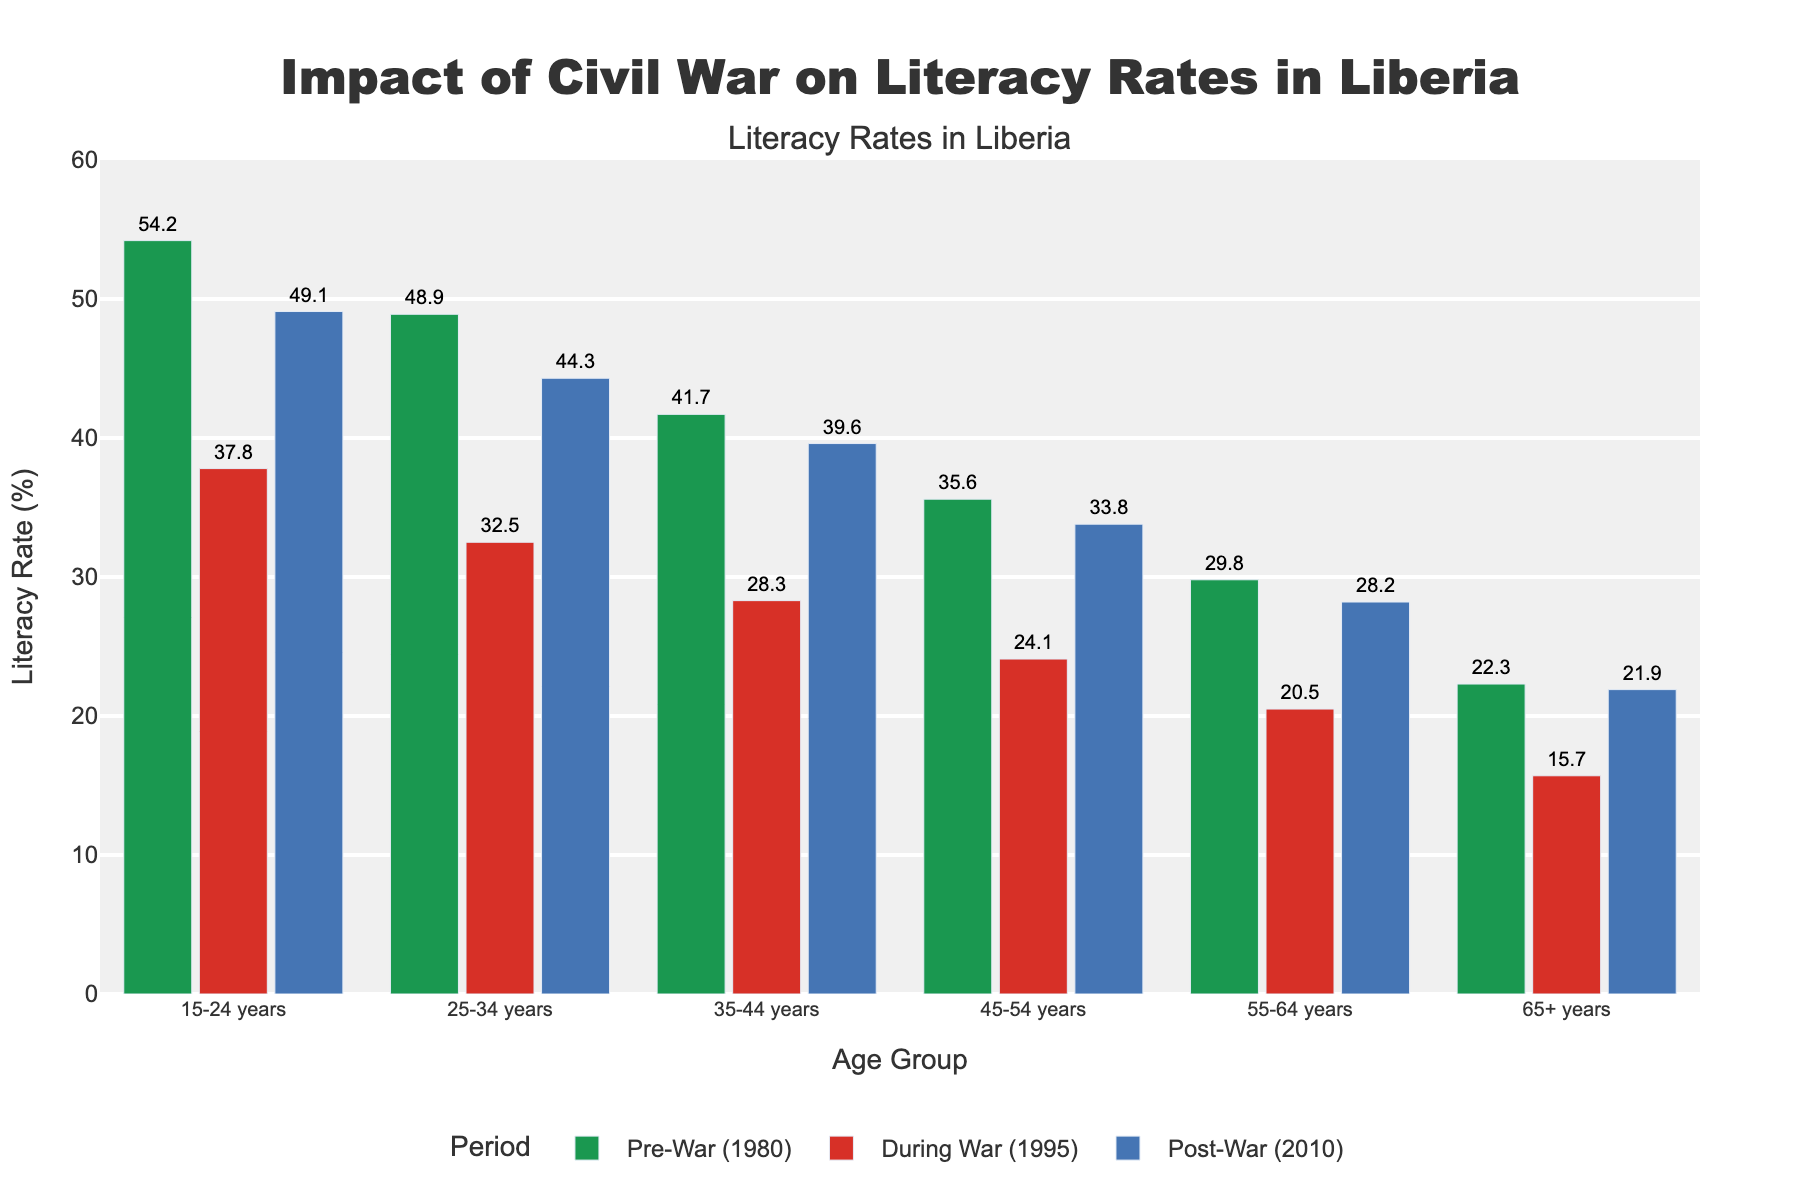What was the overall trend in literacy rates across different age groups from Pre-War (1980) to During War (1995)? To find the overall trend, compare the literacy rates of all age groups from Pre-War (1980) to During War (1995). Each age group experienced a decrease in literacy rates. For example, the 15-24 years group dropped from 54.2% to 37.8%, and so on for each age group.
Answer: Decreasing Which age group had the smallest drop in literacy rate from Pre-War (1980) to Post-War (2010)? Calculate the difference in literacy rates between Pre-War (1980) and Post-War (2010) for each age group. The smallest drop is found by comparing these differences. The 15-24 years group had the smallest drop of 5.1% (54.2% - 49.1%).
Answer: 15-24 years Between which two time periods did the 25-34 years age group experience the most significant drop in literacy rate? Compare the differences in literacy rates for the 25-34 years age group between Pre-War to During War and During War to Post-War. The drop from Pre-War (1980) to During War (1995) is 16.4% (48.9% - 32.5%), which is greater than the drop from During War to Post-War, which is 11.8%.
Answer: Pre-War to During War What is the literacy rate difference between the 35-44 years and 65+ years age groups in Post-War (2010)? Subtract the literacy rate of the 65+ years age group (21.9%) from that of the 35-44 years age group (39.6%) in Post-War (2010).
Answer: 17.7% Which age group had the highest literacy rate during the war? Look at the literacy rates for all age groups during the war period (1995). The age group with the highest value is the 15-24 years group with a literacy rate of 37.8%.
Answer: 15-24 years How did the literacy rate of the 45-54 years age group change from Pre-War (1980) to Post-War (2010)? Subtract the Pre-War literacy rate (35.6%) from the Post-War literacy rate (33.8%) for the 45-54 years age group. This gives a change of -1.8%, indicating a decrease.
Answer: Decrease by 1.8% What is the average literacy rate of all age groups during the Post-War (2010) period? Sum the literacy rates of all age groups during the Post-War (2010) period (49.1%, 44.3%, 39.6%, 33.8%, 28.2%, 21.9%) and divide by the number of age groups (6). (49.1 + 44.3 + 39.6 + 33.8 + 28.2 + 21.9) / 6 = 36.15
Answer: 36.15% Which age group saw the least change in literacy rate between During War (1995) and Post-War (2010)? Calculate the change in literacy rates for each age group between During War (1995) and Post-War (2010). The smallest change is seen by the 65+ years age group, which had a change of 6.2% (21.9% - 15.7%).
Answer: 65+ years 